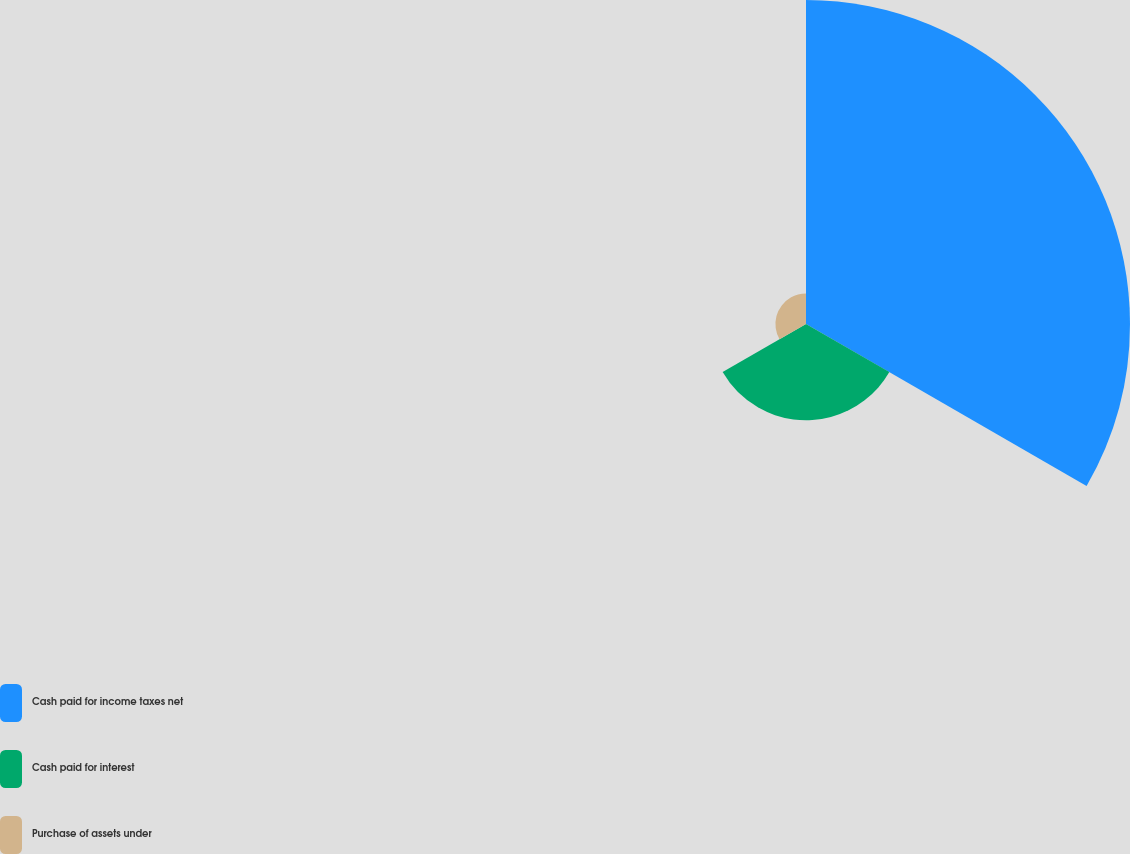<chart> <loc_0><loc_0><loc_500><loc_500><pie_chart><fcel>Cash paid for income taxes net<fcel>Cash paid for interest<fcel>Purchase of assets under<nl><fcel>71.87%<fcel>21.35%<fcel>6.78%<nl></chart> 